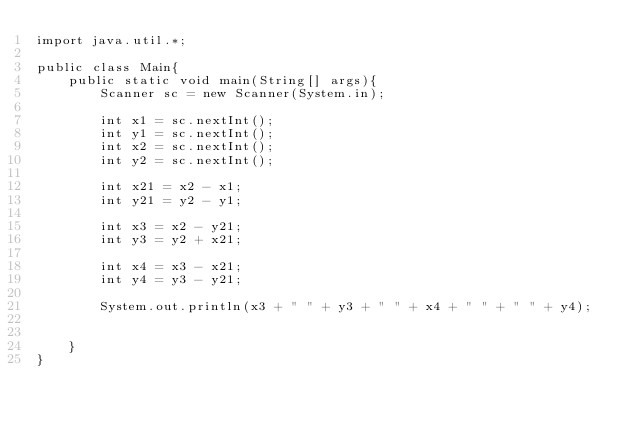<code> <loc_0><loc_0><loc_500><loc_500><_Java_>import java.util.*;

public class Main{
    public static void main(String[] args){
        Scanner sc = new Scanner(System.in);

        int x1 = sc.nextInt();
        int y1 = sc.nextInt();
        int x2 = sc.nextInt();
        int y2 = sc.nextInt();

        int x21 = x2 - x1;
        int y21 = y2 - y1;
        
        int x3 = x2 - y21;
        int y3 = y2 + x21;

        int x4 = x3 - x21;
        int y4 = y3 - y21;

        System.out.println(x3 + " " + y3 + " " + x4 + " " + " " + y4);


    }
}</code> 